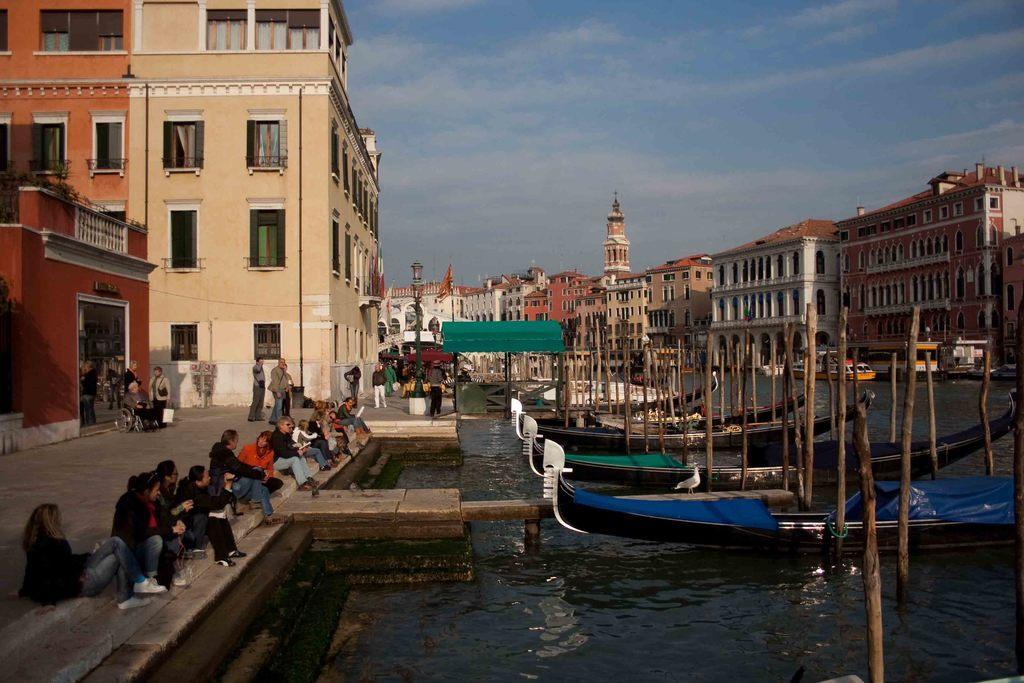Could you give a brief overview of what you see in this image? In this picture we can see boats on water, beside the water we can see a group of people on the ground, some people are standing, some people are sitting, one person is walking, another person is sitting on a wheelchair, here we can see a shed, flag, electric pole with light, buildings and some objects and we can see sky in the background. 